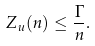<formula> <loc_0><loc_0><loc_500><loc_500>Z _ { u } ( n ) \leq \frac { \Gamma } { n } .</formula> 